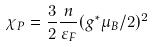Convert formula to latex. <formula><loc_0><loc_0><loc_500><loc_500>\chi _ { P } = \frac { 3 } { 2 } \frac { n } { \varepsilon _ { F } } ( g ^ { \ast } \mu _ { B } / 2 ) ^ { 2 }</formula> 